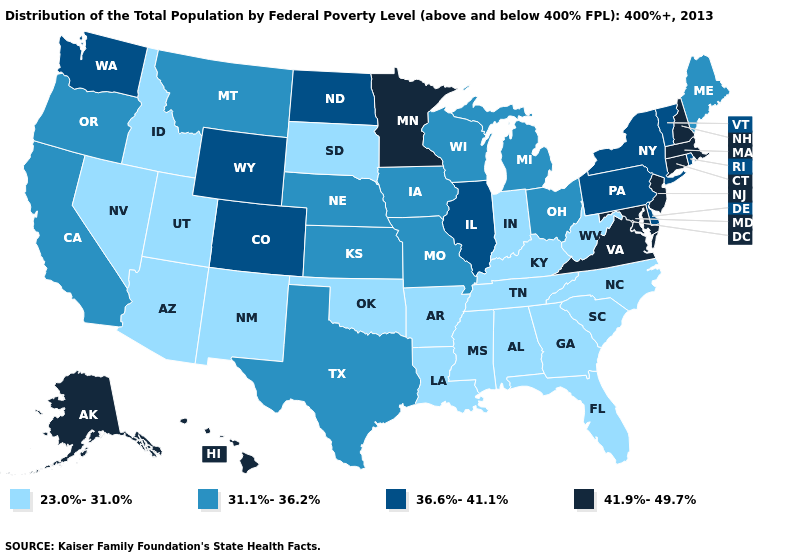Does Ohio have the highest value in the MidWest?
Short answer required. No. What is the value of Wisconsin?
Concise answer only. 31.1%-36.2%. Does Maine have the lowest value in the Northeast?
Be succinct. Yes. Name the states that have a value in the range 36.6%-41.1%?
Keep it brief. Colorado, Delaware, Illinois, New York, North Dakota, Pennsylvania, Rhode Island, Vermont, Washington, Wyoming. What is the lowest value in the USA?
Be succinct. 23.0%-31.0%. Is the legend a continuous bar?
Answer briefly. No. Does Nevada have a higher value than Iowa?
Quick response, please. No. What is the lowest value in the USA?
Give a very brief answer. 23.0%-31.0%. Does the map have missing data?
Quick response, please. No. Is the legend a continuous bar?
Be succinct. No. Does Arizona have the highest value in the West?
Be succinct. No. What is the lowest value in the USA?
Answer briefly. 23.0%-31.0%. What is the value of Kentucky?
Answer briefly. 23.0%-31.0%. Among the states that border California , does Oregon have the lowest value?
Give a very brief answer. No. What is the value of Minnesota?
Be succinct. 41.9%-49.7%. 